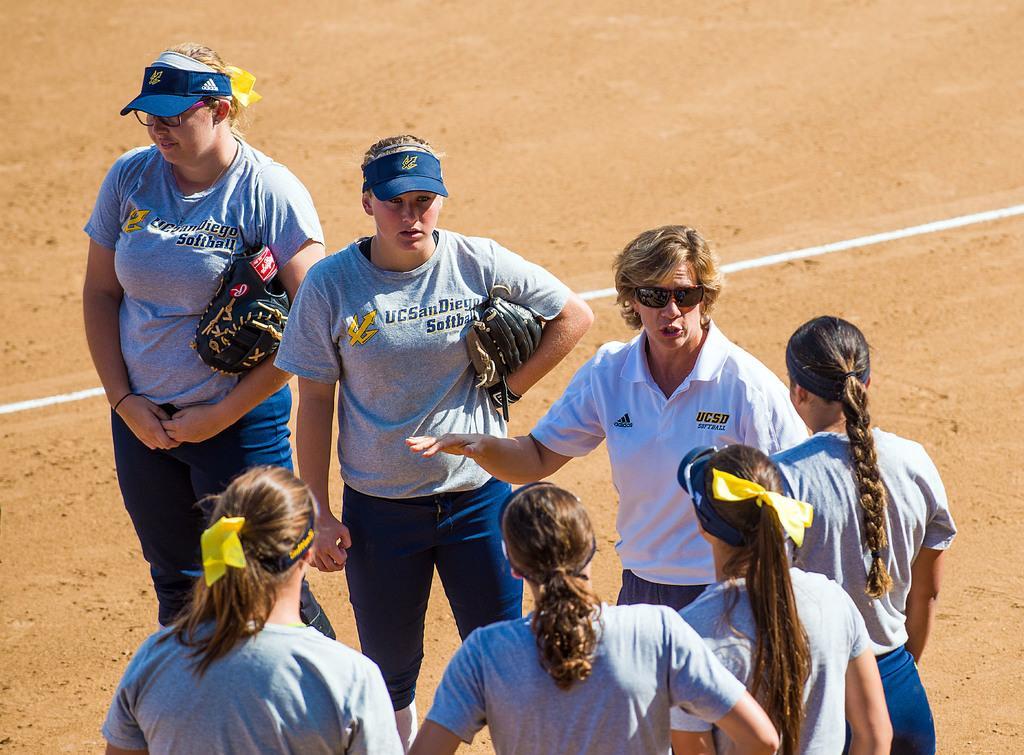Describe this image in one or two sentences. In this image there are people and ground. Among them two people are holding gloves and one person wore goggles.  